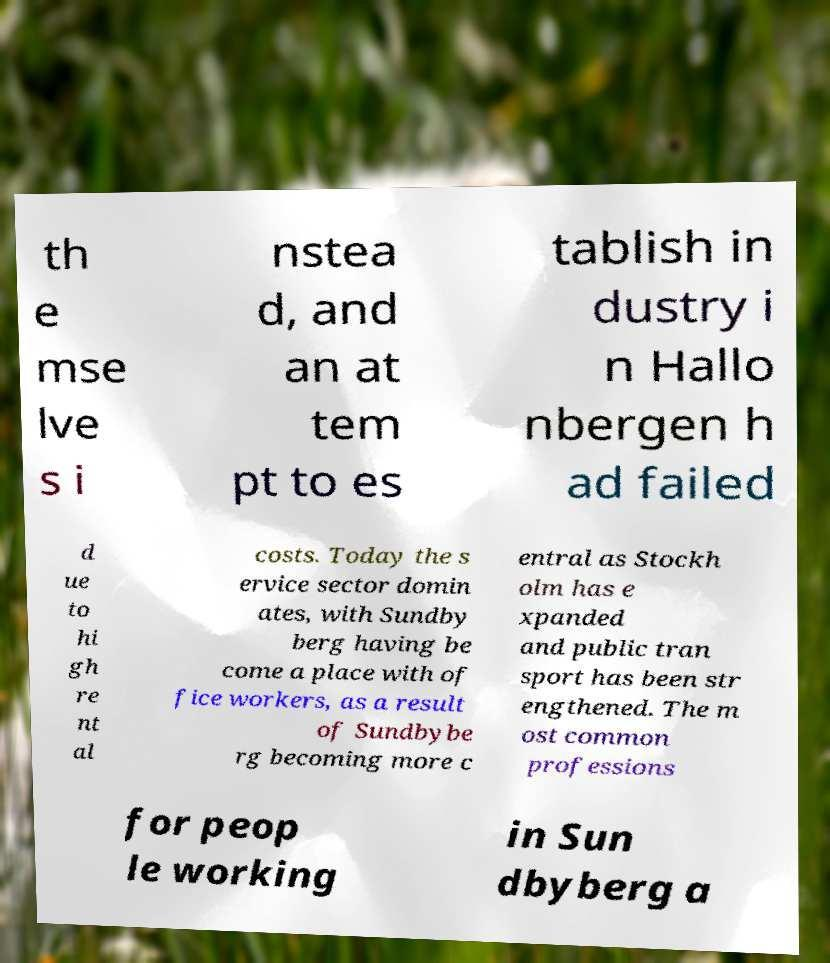There's text embedded in this image that I need extracted. Can you transcribe it verbatim? th e mse lve s i nstea d, and an at tem pt to es tablish in dustry i n Hallo nbergen h ad failed d ue to hi gh re nt al costs. Today the s ervice sector domin ates, with Sundby berg having be come a place with of fice workers, as a result of Sundbybe rg becoming more c entral as Stockh olm has e xpanded and public tran sport has been str engthened. The m ost common professions for peop le working in Sun dbyberg a 